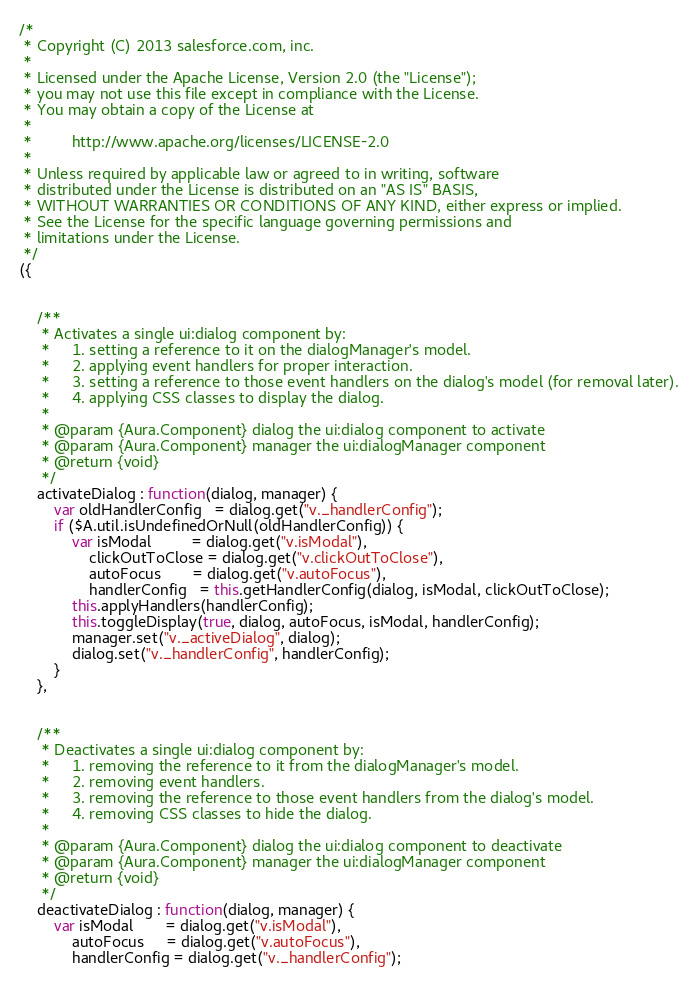Convert code to text. <code><loc_0><loc_0><loc_500><loc_500><_JavaScript_>/*
 * Copyright (C) 2013 salesforce.com, inc.
 *
 * Licensed under the Apache License, Version 2.0 (the "License");
 * you may not use this file except in compliance with the License.
 * You may obtain a copy of the License at
 *
 *         http://www.apache.org/licenses/LICENSE-2.0
 *
 * Unless required by applicable law or agreed to in writing, software
 * distributed under the License is distributed on an "AS IS" BASIS,
 * WITHOUT WARRANTIES OR CONDITIONS OF ANY KIND, either express or implied.
 * See the License for the specific language governing permissions and
 * limitations under the License.
 */
({


    /**
     * Activates a single ui:dialog component by:
     *     1. setting a reference to it on the dialogManager's model.
     *     2. applying event handlers for proper interaction.
     *     3. setting a reference to those event handlers on the dialog's model (for removal later).
     *     4. applying CSS classes to display the dialog.
     *
     * @param {Aura.Component} dialog the ui:dialog component to activate
     * @param {Aura.Component} manager the ui:dialogManager component
     * @return {void}
     */
    activateDialog : function(dialog, manager) {
        var oldHandlerConfig   = dialog.get("v._handlerConfig");
        if ($A.util.isUndefinedOrNull(oldHandlerConfig)) {
            var isModal         = dialog.get("v.isModal"),
                clickOutToClose = dialog.get("v.clickOutToClose"),
                autoFocus       = dialog.get("v.autoFocus"),
                handlerConfig   = this.getHandlerConfig(dialog, isModal, clickOutToClose);
            this.applyHandlers(handlerConfig);
            this.toggleDisplay(true, dialog, autoFocus, isModal, handlerConfig);
            manager.set("v._activeDialog", dialog);
            dialog.set("v._handlerConfig", handlerConfig);
        }
    },


    /**
     * Deactivates a single ui:dialog component by:
     *     1. removing the reference to it from the dialogManager's model.
     *     2. removing event handlers.
     *     3. removing the reference to those event handlers from the dialog's model.
     *     4. removing CSS classes to hide the dialog.
     *
     * @param {Aura.Component} dialog the ui:dialog component to deactivate
     * @param {Aura.Component} manager the ui:dialogManager component
     * @return {void}
     */
    deactivateDialog : function(dialog, manager) {
        var isModal       = dialog.get("v.isModal"),
            autoFocus     = dialog.get("v.autoFocus"),
            handlerConfig = dialog.get("v._handlerConfig");</code> 